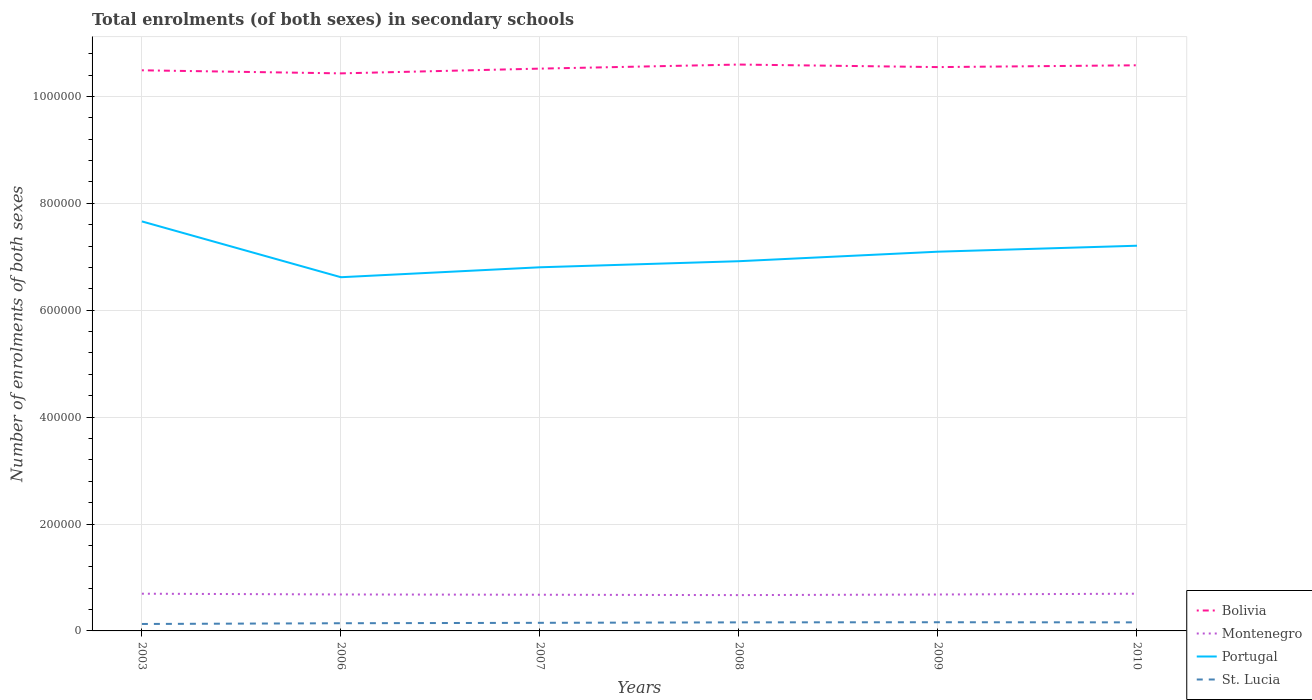Does the line corresponding to Portugal intersect with the line corresponding to St. Lucia?
Offer a very short reply. No. Across all years, what is the maximum number of enrolments in secondary schools in Portugal?
Offer a very short reply. 6.62e+05. What is the total number of enrolments in secondary schools in Bolivia in the graph?
Offer a terse response. -1.65e+04. What is the difference between the highest and the second highest number of enrolments in secondary schools in Montenegro?
Your response must be concise. 2612. Are the values on the major ticks of Y-axis written in scientific E-notation?
Your response must be concise. No. Does the graph contain grids?
Give a very brief answer. Yes. What is the title of the graph?
Provide a succinct answer. Total enrolments (of both sexes) in secondary schools. Does "Malaysia" appear as one of the legend labels in the graph?
Your answer should be very brief. No. What is the label or title of the Y-axis?
Make the answer very short. Number of enrolments of both sexes. What is the Number of enrolments of both sexes in Bolivia in 2003?
Your answer should be compact. 1.05e+06. What is the Number of enrolments of both sexes in Montenegro in 2003?
Your answer should be compact. 6.96e+04. What is the Number of enrolments of both sexes in Portugal in 2003?
Ensure brevity in your answer.  7.66e+05. What is the Number of enrolments of both sexes of St. Lucia in 2003?
Your answer should be compact. 1.30e+04. What is the Number of enrolments of both sexes in Bolivia in 2006?
Make the answer very short. 1.04e+06. What is the Number of enrolments of both sexes in Montenegro in 2006?
Your answer should be very brief. 6.82e+04. What is the Number of enrolments of both sexes in Portugal in 2006?
Give a very brief answer. 6.62e+05. What is the Number of enrolments of both sexes in St. Lucia in 2006?
Provide a succinct answer. 1.44e+04. What is the Number of enrolments of both sexes of Bolivia in 2007?
Your answer should be very brief. 1.05e+06. What is the Number of enrolments of both sexes in Montenegro in 2007?
Your answer should be compact. 6.77e+04. What is the Number of enrolments of both sexes of Portugal in 2007?
Ensure brevity in your answer.  6.80e+05. What is the Number of enrolments of both sexes of St. Lucia in 2007?
Offer a terse response. 1.51e+04. What is the Number of enrolments of both sexes in Bolivia in 2008?
Provide a short and direct response. 1.06e+06. What is the Number of enrolments of both sexes of Montenegro in 2008?
Your response must be concise. 6.70e+04. What is the Number of enrolments of both sexes of Portugal in 2008?
Give a very brief answer. 6.92e+05. What is the Number of enrolments of both sexes of St. Lucia in 2008?
Provide a succinct answer. 1.60e+04. What is the Number of enrolments of both sexes in Bolivia in 2009?
Offer a terse response. 1.05e+06. What is the Number of enrolments of both sexes of Montenegro in 2009?
Your answer should be very brief. 6.81e+04. What is the Number of enrolments of both sexes in Portugal in 2009?
Provide a short and direct response. 7.10e+05. What is the Number of enrolments of both sexes in St. Lucia in 2009?
Your answer should be compact. 1.62e+04. What is the Number of enrolments of both sexes in Bolivia in 2010?
Your response must be concise. 1.06e+06. What is the Number of enrolments of both sexes in Montenegro in 2010?
Provide a short and direct response. 6.96e+04. What is the Number of enrolments of both sexes in Portugal in 2010?
Your answer should be compact. 7.21e+05. What is the Number of enrolments of both sexes in St. Lucia in 2010?
Provide a succinct answer. 1.60e+04. Across all years, what is the maximum Number of enrolments of both sexes in Bolivia?
Keep it short and to the point. 1.06e+06. Across all years, what is the maximum Number of enrolments of both sexes in Montenegro?
Your answer should be very brief. 6.96e+04. Across all years, what is the maximum Number of enrolments of both sexes in Portugal?
Offer a terse response. 7.66e+05. Across all years, what is the maximum Number of enrolments of both sexes of St. Lucia?
Provide a succinct answer. 1.62e+04. Across all years, what is the minimum Number of enrolments of both sexes in Bolivia?
Your response must be concise. 1.04e+06. Across all years, what is the minimum Number of enrolments of both sexes in Montenegro?
Your answer should be compact. 6.70e+04. Across all years, what is the minimum Number of enrolments of both sexes of Portugal?
Your answer should be very brief. 6.62e+05. Across all years, what is the minimum Number of enrolments of both sexes of St. Lucia?
Your answer should be very brief. 1.30e+04. What is the total Number of enrolments of both sexes of Bolivia in the graph?
Make the answer very short. 6.32e+06. What is the total Number of enrolments of both sexes in Montenegro in the graph?
Your answer should be very brief. 4.10e+05. What is the total Number of enrolments of both sexes of Portugal in the graph?
Your response must be concise. 4.23e+06. What is the total Number of enrolments of both sexes in St. Lucia in the graph?
Ensure brevity in your answer.  9.08e+04. What is the difference between the Number of enrolments of both sexes in Bolivia in 2003 and that in 2006?
Keep it short and to the point. 5754. What is the difference between the Number of enrolments of both sexes of Montenegro in 2003 and that in 2006?
Provide a succinct answer. 1409. What is the difference between the Number of enrolments of both sexes in Portugal in 2003 and that in 2006?
Give a very brief answer. 1.04e+05. What is the difference between the Number of enrolments of both sexes in St. Lucia in 2003 and that in 2006?
Offer a terse response. -1390. What is the difference between the Number of enrolments of both sexes of Bolivia in 2003 and that in 2007?
Your response must be concise. -3133. What is the difference between the Number of enrolments of both sexes in Montenegro in 2003 and that in 2007?
Provide a short and direct response. 1944. What is the difference between the Number of enrolments of both sexes in Portugal in 2003 and that in 2007?
Offer a terse response. 8.58e+04. What is the difference between the Number of enrolments of both sexes in St. Lucia in 2003 and that in 2007?
Your answer should be very brief. -2159. What is the difference between the Number of enrolments of both sexes in Bolivia in 2003 and that in 2008?
Make the answer very short. -1.08e+04. What is the difference between the Number of enrolments of both sexes of Montenegro in 2003 and that in 2008?
Provide a short and direct response. 2612. What is the difference between the Number of enrolments of both sexes of Portugal in 2003 and that in 2008?
Offer a terse response. 7.45e+04. What is the difference between the Number of enrolments of both sexes in St. Lucia in 2003 and that in 2008?
Offer a very short reply. -3027. What is the difference between the Number of enrolments of both sexes in Bolivia in 2003 and that in 2009?
Give a very brief answer. -5997. What is the difference between the Number of enrolments of both sexes of Montenegro in 2003 and that in 2009?
Make the answer very short. 1492. What is the difference between the Number of enrolments of both sexes of Portugal in 2003 and that in 2009?
Keep it short and to the point. 5.67e+04. What is the difference between the Number of enrolments of both sexes of St. Lucia in 2003 and that in 2009?
Make the answer very short. -3247. What is the difference between the Number of enrolments of both sexes of Bolivia in 2003 and that in 2010?
Provide a succinct answer. -9376. What is the difference between the Number of enrolments of both sexes in Montenegro in 2003 and that in 2010?
Make the answer very short. 8. What is the difference between the Number of enrolments of both sexes in Portugal in 2003 and that in 2010?
Give a very brief answer. 4.55e+04. What is the difference between the Number of enrolments of both sexes of St. Lucia in 2003 and that in 2010?
Your answer should be very brief. -3030. What is the difference between the Number of enrolments of both sexes of Bolivia in 2006 and that in 2007?
Provide a short and direct response. -8887. What is the difference between the Number of enrolments of both sexes of Montenegro in 2006 and that in 2007?
Make the answer very short. 535. What is the difference between the Number of enrolments of both sexes of Portugal in 2006 and that in 2007?
Give a very brief answer. -1.86e+04. What is the difference between the Number of enrolments of both sexes in St. Lucia in 2006 and that in 2007?
Ensure brevity in your answer.  -769. What is the difference between the Number of enrolments of both sexes in Bolivia in 2006 and that in 2008?
Provide a short and direct response. -1.65e+04. What is the difference between the Number of enrolments of both sexes of Montenegro in 2006 and that in 2008?
Keep it short and to the point. 1203. What is the difference between the Number of enrolments of both sexes of Portugal in 2006 and that in 2008?
Provide a short and direct response. -3.00e+04. What is the difference between the Number of enrolments of both sexes in St. Lucia in 2006 and that in 2008?
Provide a short and direct response. -1637. What is the difference between the Number of enrolments of both sexes in Bolivia in 2006 and that in 2009?
Offer a terse response. -1.18e+04. What is the difference between the Number of enrolments of both sexes in Montenegro in 2006 and that in 2009?
Offer a terse response. 83. What is the difference between the Number of enrolments of both sexes in Portugal in 2006 and that in 2009?
Your answer should be compact. -4.78e+04. What is the difference between the Number of enrolments of both sexes of St. Lucia in 2006 and that in 2009?
Provide a succinct answer. -1857. What is the difference between the Number of enrolments of both sexes in Bolivia in 2006 and that in 2010?
Ensure brevity in your answer.  -1.51e+04. What is the difference between the Number of enrolments of both sexes in Montenegro in 2006 and that in 2010?
Make the answer very short. -1401. What is the difference between the Number of enrolments of both sexes of Portugal in 2006 and that in 2010?
Provide a succinct answer. -5.89e+04. What is the difference between the Number of enrolments of both sexes of St. Lucia in 2006 and that in 2010?
Your answer should be very brief. -1640. What is the difference between the Number of enrolments of both sexes in Bolivia in 2007 and that in 2008?
Give a very brief answer. -7627. What is the difference between the Number of enrolments of both sexes in Montenegro in 2007 and that in 2008?
Offer a very short reply. 668. What is the difference between the Number of enrolments of both sexes in Portugal in 2007 and that in 2008?
Your answer should be compact. -1.14e+04. What is the difference between the Number of enrolments of both sexes of St. Lucia in 2007 and that in 2008?
Offer a very short reply. -868. What is the difference between the Number of enrolments of both sexes in Bolivia in 2007 and that in 2009?
Offer a very short reply. -2864. What is the difference between the Number of enrolments of both sexes in Montenegro in 2007 and that in 2009?
Keep it short and to the point. -452. What is the difference between the Number of enrolments of both sexes of Portugal in 2007 and that in 2009?
Make the answer very short. -2.92e+04. What is the difference between the Number of enrolments of both sexes in St. Lucia in 2007 and that in 2009?
Ensure brevity in your answer.  -1088. What is the difference between the Number of enrolments of both sexes in Bolivia in 2007 and that in 2010?
Keep it short and to the point. -6243. What is the difference between the Number of enrolments of both sexes in Montenegro in 2007 and that in 2010?
Your response must be concise. -1936. What is the difference between the Number of enrolments of both sexes of Portugal in 2007 and that in 2010?
Your answer should be compact. -4.04e+04. What is the difference between the Number of enrolments of both sexes of St. Lucia in 2007 and that in 2010?
Your answer should be compact. -871. What is the difference between the Number of enrolments of both sexes in Bolivia in 2008 and that in 2009?
Keep it short and to the point. 4763. What is the difference between the Number of enrolments of both sexes in Montenegro in 2008 and that in 2009?
Offer a very short reply. -1120. What is the difference between the Number of enrolments of both sexes in Portugal in 2008 and that in 2009?
Your answer should be very brief. -1.78e+04. What is the difference between the Number of enrolments of both sexes of St. Lucia in 2008 and that in 2009?
Provide a short and direct response. -220. What is the difference between the Number of enrolments of both sexes in Bolivia in 2008 and that in 2010?
Keep it short and to the point. 1384. What is the difference between the Number of enrolments of both sexes of Montenegro in 2008 and that in 2010?
Give a very brief answer. -2604. What is the difference between the Number of enrolments of both sexes of Portugal in 2008 and that in 2010?
Your response must be concise. -2.90e+04. What is the difference between the Number of enrolments of both sexes in Bolivia in 2009 and that in 2010?
Keep it short and to the point. -3379. What is the difference between the Number of enrolments of both sexes of Montenegro in 2009 and that in 2010?
Make the answer very short. -1484. What is the difference between the Number of enrolments of both sexes of Portugal in 2009 and that in 2010?
Keep it short and to the point. -1.12e+04. What is the difference between the Number of enrolments of both sexes of St. Lucia in 2009 and that in 2010?
Make the answer very short. 217. What is the difference between the Number of enrolments of both sexes of Bolivia in 2003 and the Number of enrolments of both sexes of Montenegro in 2006?
Keep it short and to the point. 9.81e+05. What is the difference between the Number of enrolments of both sexes of Bolivia in 2003 and the Number of enrolments of both sexes of Portugal in 2006?
Offer a very short reply. 3.87e+05. What is the difference between the Number of enrolments of both sexes of Bolivia in 2003 and the Number of enrolments of both sexes of St. Lucia in 2006?
Your response must be concise. 1.03e+06. What is the difference between the Number of enrolments of both sexes in Montenegro in 2003 and the Number of enrolments of both sexes in Portugal in 2006?
Offer a terse response. -5.92e+05. What is the difference between the Number of enrolments of both sexes in Montenegro in 2003 and the Number of enrolments of both sexes in St. Lucia in 2006?
Provide a short and direct response. 5.52e+04. What is the difference between the Number of enrolments of both sexes of Portugal in 2003 and the Number of enrolments of both sexes of St. Lucia in 2006?
Provide a succinct answer. 7.52e+05. What is the difference between the Number of enrolments of both sexes of Bolivia in 2003 and the Number of enrolments of both sexes of Montenegro in 2007?
Your answer should be compact. 9.81e+05. What is the difference between the Number of enrolments of both sexes in Bolivia in 2003 and the Number of enrolments of both sexes in Portugal in 2007?
Your response must be concise. 3.69e+05. What is the difference between the Number of enrolments of both sexes of Bolivia in 2003 and the Number of enrolments of both sexes of St. Lucia in 2007?
Your answer should be compact. 1.03e+06. What is the difference between the Number of enrolments of both sexes in Montenegro in 2003 and the Number of enrolments of both sexes in Portugal in 2007?
Give a very brief answer. -6.11e+05. What is the difference between the Number of enrolments of both sexes of Montenegro in 2003 and the Number of enrolments of both sexes of St. Lucia in 2007?
Your response must be concise. 5.45e+04. What is the difference between the Number of enrolments of both sexes in Portugal in 2003 and the Number of enrolments of both sexes in St. Lucia in 2007?
Provide a succinct answer. 7.51e+05. What is the difference between the Number of enrolments of both sexes in Bolivia in 2003 and the Number of enrolments of both sexes in Montenegro in 2008?
Offer a very short reply. 9.82e+05. What is the difference between the Number of enrolments of both sexes of Bolivia in 2003 and the Number of enrolments of both sexes of Portugal in 2008?
Make the answer very short. 3.57e+05. What is the difference between the Number of enrolments of both sexes in Bolivia in 2003 and the Number of enrolments of both sexes in St. Lucia in 2008?
Ensure brevity in your answer.  1.03e+06. What is the difference between the Number of enrolments of both sexes in Montenegro in 2003 and the Number of enrolments of both sexes in Portugal in 2008?
Give a very brief answer. -6.22e+05. What is the difference between the Number of enrolments of both sexes of Montenegro in 2003 and the Number of enrolments of both sexes of St. Lucia in 2008?
Offer a terse response. 5.36e+04. What is the difference between the Number of enrolments of both sexes of Portugal in 2003 and the Number of enrolments of both sexes of St. Lucia in 2008?
Keep it short and to the point. 7.50e+05. What is the difference between the Number of enrolments of both sexes of Bolivia in 2003 and the Number of enrolments of both sexes of Montenegro in 2009?
Your answer should be compact. 9.81e+05. What is the difference between the Number of enrolments of both sexes in Bolivia in 2003 and the Number of enrolments of both sexes in Portugal in 2009?
Ensure brevity in your answer.  3.39e+05. What is the difference between the Number of enrolments of both sexes of Bolivia in 2003 and the Number of enrolments of both sexes of St. Lucia in 2009?
Give a very brief answer. 1.03e+06. What is the difference between the Number of enrolments of both sexes of Montenegro in 2003 and the Number of enrolments of both sexes of Portugal in 2009?
Your answer should be very brief. -6.40e+05. What is the difference between the Number of enrolments of both sexes of Montenegro in 2003 and the Number of enrolments of both sexes of St. Lucia in 2009?
Make the answer very short. 5.34e+04. What is the difference between the Number of enrolments of both sexes of Portugal in 2003 and the Number of enrolments of both sexes of St. Lucia in 2009?
Keep it short and to the point. 7.50e+05. What is the difference between the Number of enrolments of both sexes in Bolivia in 2003 and the Number of enrolments of both sexes in Montenegro in 2010?
Your answer should be compact. 9.79e+05. What is the difference between the Number of enrolments of both sexes of Bolivia in 2003 and the Number of enrolments of both sexes of Portugal in 2010?
Your answer should be very brief. 3.28e+05. What is the difference between the Number of enrolments of both sexes of Bolivia in 2003 and the Number of enrolments of both sexes of St. Lucia in 2010?
Make the answer very short. 1.03e+06. What is the difference between the Number of enrolments of both sexes in Montenegro in 2003 and the Number of enrolments of both sexes in Portugal in 2010?
Your response must be concise. -6.51e+05. What is the difference between the Number of enrolments of both sexes of Montenegro in 2003 and the Number of enrolments of both sexes of St. Lucia in 2010?
Your answer should be compact. 5.36e+04. What is the difference between the Number of enrolments of both sexes in Portugal in 2003 and the Number of enrolments of both sexes in St. Lucia in 2010?
Provide a succinct answer. 7.50e+05. What is the difference between the Number of enrolments of both sexes in Bolivia in 2006 and the Number of enrolments of both sexes in Montenegro in 2007?
Your answer should be very brief. 9.75e+05. What is the difference between the Number of enrolments of both sexes of Bolivia in 2006 and the Number of enrolments of both sexes of Portugal in 2007?
Provide a short and direct response. 3.63e+05. What is the difference between the Number of enrolments of both sexes in Bolivia in 2006 and the Number of enrolments of both sexes in St. Lucia in 2007?
Your answer should be compact. 1.03e+06. What is the difference between the Number of enrolments of both sexes in Montenegro in 2006 and the Number of enrolments of both sexes in Portugal in 2007?
Ensure brevity in your answer.  -6.12e+05. What is the difference between the Number of enrolments of both sexes of Montenegro in 2006 and the Number of enrolments of both sexes of St. Lucia in 2007?
Make the answer very short. 5.31e+04. What is the difference between the Number of enrolments of both sexes in Portugal in 2006 and the Number of enrolments of both sexes in St. Lucia in 2007?
Ensure brevity in your answer.  6.47e+05. What is the difference between the Number of enrolments of both sexes in Bolivia in 2006 and the Number of enrolments of both sexes in Montenegro in 2008?
Your answer should be very brief. 9.76e+05. What is the difference between the Number of enrolments of both sexes in Bolivia in 2006 and the Number of enrolments of both sexes in Portugal in 2008?
Offer a very short reply. 3.51e+05. What is the difference between the Number of enrolments of both sexes in Bolivia in 2006 and the Number of enrolments of both sexes in St. Lucia in 2008?
Provide a short and direct response. 1.03e+06. What is the difference between the Number of enrolments of both sexes in Montenegro in 2006 and the Number of enrolments of both sexes in Portugal in 2008?
Your answer should be very brief. -6.23e+05. What is the difference between the Number of enrolments of both sexes in Montenegro in 2006 and the Number of enrolments of both sexes in St. Lucia in 2008?
Your answer should be very brief. 5.22e+04. What is the difference between the Number of enrolments of both sexes in Portugal in 2006 and the Number of enrolments of both sexes in St. Lucia in 2008?
Make the answer very short. 6.46e+05. What is the difference between the Number of enrolments of both sexes of Bolivia in 2006 and the Number of enrolments of both sexes of Montenegro in 2009?
Give a very brief answer. 9.75e+05. What is the difference between the Number of enrolments of both sexes in Bolivia in 2006 and the Number of enrolments of both sexes in Portugal in 2009?
Provide a succinct answer. 3.34e+05. What is the difference between the Number of enrolments of both sexes in Bolivia in 2006 and the Number of enrolments of both sexes in St. Lucia in 2009?
Offer a very short reply. 1.03e+06. What is the difference between the Number of enrolments of both sexes in Montenegro in 2006 and the Number of enrolments of both sexes in Portugal in 2009?
Your answer should be very brief. -6.41e+05. What is the difference between the Number of enrolments of both sexes of Montenegro in 2006 and the Number of enrolments of both sexes of St. Lucia in 2009?
Your response must be concise. 5.20e+04. What is the difference between the Number of enrolments of both sexes of Portugal in 2006 and the Number of enrolments of both sexes of St. Lucia in 2009?
Your response must be concise. 6.46e+05. What is the difference between the Number of enrolments of both sexes in Bolivia in 2006 and the Number of enrolments of both sexes in Montenegro in 2010?
Offer a very short reply. 9.74e+05. What is the difference between the Number of enrolments of both sexes in Bolivia in 2006 and the Number of enrolments of both sexes in Portugal in 2010?
Your answer should be very brief. 3.22e+05. What is the difference between the Number of enrolments of both sexes in Bolivia in 2006 and the Number of enrolments of both sexes in St. Lucia in 2010?
Your answer should be very brief. 1.03e+06. What is the difference between the Number of enrolments of both sexes in Montenegro in 2006 and the Number of enrolments of both sexes in Portugal in 2010?
Provide a succinct answer. -6.52e+05. What is the difference between the Number of enrolments of both sexes in Montenegro in 2006 and the Number of enrolments of both sexes in St. Lucia in 2010?
Provide a succinct answer. 5.22e+04. What is the difference between the Number of enrolments of both sexes of Portugal in 2006 and the Number of enrolments of both sexes of St. Lucia in 2010?
Provide a short and direct response. 6.46e+05. What is the difference between the Number of enrolments of both sexes in Bolivia in 2007 and the Number of enrolments of both sexes in Montenegro in 2008?
Your answer should be very brief. 9.85e+05. What is the difference between the Number of enrolments of both sexes in Bolivia in 2007 and the Number of enrolments of both sexes in Portugal in 2008?
Offer a very short reply. 3.60e+05. What is the difference between the Number of enrolments of both sexes in Bolivia in 2007 and the Number of enrolments of both sexes in St. Lucia in 2008?
Give a very brief answer. 1.04e+06. What is the difference between the Number of enrolments of both sexes of Montenegro in 2007 and the Number of enrolments of both sexes of Portugal in 2008?
Keep it short and to the point. -6.24e+05. What is the difference between the Number of enrolments of both sexes of Montenegro in 2007 and the Number of enrolments of both sexes of St. Lucia in 2008?
Offer a terse response. 5.17e+04. What is the difference between the Number of enrolments of both sexes of Portugal in 2007 and the Number of enrolments of both sexes of St. Lucia in 2008?
Provide a short and direct response. 6.64e+05. What is the difference between the Number of enrolments of both sexes of Bolivia in 2007 and the Number of enrolments of both sexes of Montenegro in 2009?
Offer a very short reply. 9.84e+05. What is the difference between the Number of enrolments of both sexes in Bolivia in 2007 and the Number of enrolments of both sexes in Portugal in 2009?
Your response must be concise. 3.42e+05. What is the difference between the Number of enrolments of both sexes of Bolivia in 2007 and the Number of enrolments of both sexes of St. Lucia in 2009?
Keep it short and to the point. 1.04e+06. What is the difference between the Number of enrolments of both sexes in Montenegro in 2007 and the Number of enrolments of both sexes in Portugal in 2009?
Your answer should be compact. -6.42e+05. What is the difference between the Number of enrolments of both sexes in Montenegro in 2007 and the Number of enrolments of both sexes in St. Lucia in 2009?
Make the answer very short. 5.14e+04. What is the difference between the Number of enrolments of both sexes of Portugal in 2007 and the Number of enrolments of both sexes of St. Lucia in 2009?
Keep it short and to the point. 6.64e+05. What is the difference between the Number of enrolments of both sexes in Bolivia in 2007 and the Number of enrolments of both sexes in Montenegro in 2010?
Your answer should be very brief. 9.82e+05. What is the difference between the Number of enrolments of both sexes of Bolivia in 2007 and the Number of enrolments of both sexes of Portugal in 2010?
Offer a terse response. 3.31e+05. What is the difference between the Number of enrolments of both sexes in Bolivia in 2007 and the Number of enrolments of both sexes in St. Lucia in 2010?
Offer a very short reply. 1.04e+06. What is the difference between the Number of enrolments of both sexes of Montenegro in 2007 and the Number of enrolments of both sexes of Portugal in 2010?
Your answer should be very brief. -6.53e+05. What is the difference between the Number of enrolments of both sexes in Montenegro in 2007 and the Number of enrolments of both sexes in St. Lucia in 2010?
Ensure brevity in your answer.  5.17e+04. What is the difference between the Number of enrolments of both sexes of Portugal in 2007 and the Number of enrolments of both sexes of St. Lucia in 2010?
Offer a very short reply. 6.64e+05. What is the difference between the Number of enrolments of both sexes in Bolivia in 2008 and the Number of enrolments of both sexes in Montenegro in 2009?
Offer a very short reply. 9.92e+05. What is the difference between the Number of enrolments of both sexes in Bolivia in 2008 and the Number of enrolments of both sexes in Portugal in 2009?
Keep it short and to the point. 3.50e+05. What is the difference between the Number of enrolments of both sexes of Bolivia in 2008 and the Number of enrolments of both sexes of St. Lucia in 2009?
Your answer should be compact. 1.04e+06. What is the difference between the Number of enrolments of both sexes of Montenegro in 2008 and the Number of enrolments of both sexes of Portugal in 2009?
Give a very brief answer. -6.43e+05. What is the difference between the Number of enrolments of both sexes of Montenegro in 2008 and the Number of enrolments of both sexes of St. Lucia in 2009?
Your answer should be very brief. 5.08e+04. What is the difference between the Number of enrolments of both sexes of Portugal in 2008 and the Number of enrolments of both sexes of St. Lucia in 2009?
Offer a terse response. 6.75e+05. What is the difference between the Number of enrolments of both sexes in Bolivia in 2008 and the Number of enrolments of both sexes in Montenegro in 2010?
Offer a terse response. 9.90e+05. What is the difference between the Number of enrolments of both sexes of Bolivia in 2008 and the Number of enrolments of both sexes of Portugal in 2010?
Ensure brevity in your answer.  3.39e+05. What is the difference between the Number of enrolments of both sexes in Bolivia in 2008 and the Number of enrolments of both sexes in St. Lucia in 2010?
Provide a succinct answer. 1.04e+06. What is the difference between the Number of enrolments of both sexes of Montenegro in 2008 and the Number of enrolments of both sexes of Portugal in 2010?
Your answer should be very brief. -6.54e+05. What is the difference between the Number of enrolments of both sexes in Montenegro in 2008 and the Number of enrolments of both sexes in St. Lucia in 2010?
Your response must be concise. 5.10e+04. What is the difference between the Number of enrolments of both sexes in Portugal in 2008 and the Number of enrolments of both sexes in St. Lucia in 2010?
Keep it short and to the point. 6.76e+05. What is the difference between the Number of enrolments of both sexes of Bolivia in 2009 and the Number of enrolments of both sexes of Montenegro in 2010?
Keep it short and to the point. 9.85e+05. What is the difference between the Number of enrolments of both sexes of Bolivia in 2009 and the Number of enrolments of both sexes of Portugal in 2010?
Provide a succinct answer. 3.34e+05. What is the difference between the Number of enrolments of both sexes in Bolivia in 2009 and the Number of enrolments of both sexes in St. Lucia in 2010?
Provide a succinct answer. 1.04e+06. What is the difference between the Number of enrolments of both sexes in Montenegro in 2009 and the Number of enrolments of both sexes in Portugal in 2010?
Keep it short and to the point. -6.53e+05. What is the difference between the Number of enrolments of both sexes in Montenegro in 2009 and the Number of enrolments of both sexes in St. Lucia in 2010?
Your answer should be compact. 5.21e+04. What is the difference between the Number of enrolments of both sexes of Portugal in 2009 and the Number of enrolments of both sexes of St. Lucia in 2010?
Offer a terse response. 6.94e+05. What is the average Number of enrolments of both sexes of Bolivia per year?
Ensure brevity in your answer.  1.05e+06. What is the average Number of enrolments of both sexes of Montenegro per year?
Keep it short and to the point. 6.84e+04. What is the average Number of enrolments of both sexes in Portugal per year?
Your response must be concise. 7.05e+05. What is the average Number of enrolments of both sexes in St. Lucia per year?
Offer a very short reply. 1.51e+04. In the year 2003, what is the difference between the Number of enrolments of both sexes in Bolivia and Number of enrolments of both sexes in Montenegro?
Make the answer very short. 9.79e+05. In the year 2003, what is the difference between the Number of enrolments of both sexes of Bolivia and Number of enrolments of both sexes of Portugal?
Keep it short and to the point. 2.83e+05. In the year 2003, what is the difference between the Number of enrolments of both sexes in Bolivia and Number of enrolments of both sexes in St. Lucia?
Offer a terse response. 1.04e+06. In the year 2003, what is the difference between the Number of enrolments of both sexes of Montenegro and Number of enrolments of both sexes of Portugal?
Make the answer very short. -6.97e+05. In the year 2003, what is the difference between the Number of enrolments of both sexes of Montenegro and Number of enrolments of both sexes of St. Lucia?
Offer a very short reply. 5.66e+04. In the year 2003, what is the difference between the Number of enrolments of both sexes of Portugal and Number of enrolments of both sexes of St. Lucia?
Your answer should be very brief. 7.53e+05. In the year 2006, what is the difference between the Number of enrolments of both sexes in Bolivia and Number of enrolments of both sexes in Montenegro?
Ensure brevity in your answer.  9.75e+05. In the year 2006, what is the difference between the Number of enrolments of both sexes of Bolivia and Number of enrolments of both sexes of Portugal?
Your answer should be very brief. 3.81e+05. In the year 2006, what is the difference between the Number of enrolments of both sexes of Bolivia and Number of enrolments of both sexes of St. Lucia?
Ensure brevity in your answer.  1.03e+06. In the year 2006, what is the difference between the Number of enrolments of both sexes of Montenegro and Number of enrolments of both sexes of Portugal?
Keep it short and to the point. -5.94e+05. In the year 2006, what is the difference between the Number of enrolments of both sexes of Montenegro and Number of enrolments of both sexes of St. Lucia?
Ensure brevity in your answer.  5.38e+04. In the year 2006, what is the difference between the Number of enrolments of both sexes in Portugal and Number of enrolments of both sexes in St. Lucia?
Your answer should be very brief. 6.47e+05. In the year 2007, what is the difference between the Number of enrolments of both sexes of Bolivia and Number of enrolments of both sexes of Montenegro?
Your response must be concise. 9.84e+05. In the year 2007, what is the difference between the Number of enrolments of both sexes of Bolivia and Number of enrolments of both sexes of Portugal?
Provide a short and direct response. 3.72e+05. In the year 2007, what is the difference between the Number of enrolments of both sexes in Bolivia and Number of enrolments of both sexes in St. Lucia?
Make the answer very short. 1.04e+06. In the year 2007, what is the difference between the Number of enrolments of both sexes of Montenegro and Number of enrolments of both sexes of Portugal?
Give a very brief answer. -6.13e+05. In the year 2007, what is the difference between the Number of enrolments of both sexes in Montenegro and Number of enrolments of both sexes in St. Lucia?
Offer a very short reply. 5.25e+04. In the year 2007, what is the difference between the Number of enrolments of both sexes in Portugal and Number of enrolments of both sexes in St. Lucia?
Provide a succinct answer. 6.65e+05. In the year 2008, what is the difference between the Number of enrolments of both sexes in Bolivia and Number of enrolments of both sexes in Montenegro?
Your response must be concise. 9.93e+05. In the year 2008, what is the difference between the Number of enrolments of both sexes of Bolivia and Number of enrolments of both sexes of Portugal?
Give a very brief answer. 3.68e+05. In the year 2008, what is the difference between the Number of enrolments of both sexes of Bolivia and Number of enrolments of both sexes of St. Lucia?
Provide a succinct answer. 1.04e+06. In the year 2008, what is the difference between the Number of enrolments of both sexes of Montenegro and Number of enrolments of both sexes of Portugal?
Ensure brevity in your answer.  -6.25e+05. In the year 2008, what is the difference between the Number of enrolments of both sexes in Montenegro and Number of enrolments of both sexes in St. Lucia?
Your answer should be compact. 5.10e+04. In the year 2008, what is the difference between the Number of enrolments of both sexes of Portugal and Number of enrolments of both sexes of St. Lucia?
Give a very brief answer. 6.76e+05. In the year 2009, what is the difference between the Number of enrolments of both sexes in Bolivia and Number of enrolments of both sexes in Montenegro?
Make the answer very short. 9.87e+05. In the year 2009, what is the difference between the Number of enrolments of both sexes in Bolivia and Number of enrolments of both sexes in Portugal?
Give a very brief answer. 3.45e+05. In the year 2009, what is the difference between the Number of enrolments of both sexes in Bolivia and Number of enrolments of both sexes in St. Lucia?
Your answer should be compact. 1.04e+06. In the year 2009, what is the difference between the Number of enrolments of both sexes in Montenegro and Number of enrolments of both sexes in Portugal?
Provide a succinct answer. -6.41e+05. In the year 2009, what is the difference between the Number of enrolments of both sexes in Montenegro and Number of enrolments of both sexes in St. Lucia?
Give a very brief answer. 5.19e+04. In the year 2009, what is the difference between the Number of enrolments of both sexes of Portugal and Number of enrolments of both sexes of St. Lucia?
Your answer should be compact. 6.93e+05. In the year 2010, what is the difference between the Number of enrolments of both sexes of Bolivia and Number of enrolments of both sexes of Montenegro?
Your response must be concise. 9.89e+05. In the year 2010, what is the difference between the Number of enrolments of both sexes in Bolivia and Number of enrolments of both sexes in Portugal?
Offer a very short reply. 3.38e+05. In the year 2010, what is the difference between the Number of enrolments of both sexes in Bolivia and Number of enrolments of both sexes in St. Lucia?
Make the answer very short. 1.04e+06. In the year 2010, what is the difference between the Number of enrolments of both sexes in Montenegro and Number of enrolments of both sexes in Portugal?
Give a very brief answer. -6.51e+05. In the year 2010, what is the difference between the Number of enrolments of both sexes in Montenegro and Number of enrolments of both sexes in St. Lucia?
Keep it short and to the point. 5.36e+04. In the year 2010, what is the difference between the Number of enrolments of both sexes in Portugal and Number of enrolments of both sexes in St. Lucia?
Make the answer very short. 7.05e+05. What is the ratio of the Number of enrolments of both sexes in Montenegro in 2003 to that in 2006?
Give a very brief answer. 1.02. What is the ratio of the Number of enrolments of both sexes of Portugal in 2003 to that in 2006?
Offer a very short reply. 1.16. What is the ratio of the Number of enrolments of both sexes of St. Lucia in 2003 to that in 2006?
Provide a succinct answer. 0.9. What is the ratio of the Number of enrolments of both sexes of Bolivia in 2003 to that in 2007?
Your response must be concise. 1. What is the ratio of the Number of enrolments of both sexes in Montenegro in 2003 to that in 2007?
Give a very brief answer. 1.03. What is the ratio of the Number of enrolments of both sexes of Portugal in 2003 to that in 2007?
Ensure brevity in your answer.  1.13. What is the ratio of the Number of enrolments of both sexes of St. Lucia in 2003 to that in 2007?
Provide a succinct answer. 0.86. What is the ratio of the Number of enrolments of both sexes in Bolivia in 2003 to that in 2008?
Your response must be concise. 0.99. What is the ratio of the Number of enrolments of both sexes in Montenegro in 2003 to that in 2008?
Make the answer very short. 1.04. What is the ratio of the Number of enrolments of both sexes of Portugal in 2003 to that in 2008?
Your response must be concise. 1.11. What is the ratio of the Number of enrolments of both sexes in St. Lucia in 2003 to that in 2008?
Make the answer very short. 0.81. What is the ratio of the Number of enrolments of both sexes in Montenegro in 2003 to that in 2009?
Keep it short and to the point. 1.02. What is the ratio of the Number of enrolments of both sexes of Portugal in 2003 to that in 2009?
Provide a short and direct response. 1.08. What is the ratio of the Number of enrolments of both sexes in Portugal in 2003 to that in 2010?
Your answer should be compact. 1.06. What is the ratio of the Number of enrolments of both sexes of St. Lucia in 2003 to that in 2010?
Provide a succinct answer. 0.81. What is the ratio of the Number of enrolments of both sexes in Bolivia in 2006 to that in 2007?
Offer a terse response. 0.99. What is the ratio of the Number of enrolments of both sexes of Montenegro in 2006 to that in 2007?
Your answer should be very brief. 1.01. What is the ratio of the Number of enrolments of both sexes in Portugal in 2006 to that in 2007?
Your answer should be very brief. 0.97. What is the ratio of the Number of enrolments of both sexes in St. Lucia in 2006 to that in 2007?
Give a very brief answer. 0.95. What is the ratio of the Number of enrolments of both sexes in Bolivia in 2006 to that in 2008?
Provide a short and direct response. 0.98. What is the ratio of the Number of enrolments of both sexes in Montenegro in 2006 to that in 2008?
Offer a terse response. 1.02. What is the ratio of the Number of enrolments of both sexes in Portugal in 2006 to that in 2008?
Your response must be concise. 0.96. What is the ratio of the Number of enrolments of both sexes in St. Lucia in 2006 to that in 2008?
Your answer should be compact. 0.9. What is the ratio of the Number of enrolments of both sexes of Bolivia in 2006 to that in 2009?
Offer a very short reply. 0.99. What is the ratio of the Number of enrolments of both sexes in Montenegro in 2006 to that in 2009?
Make the answer very short. 1. What is the ratio of the Number of enrolments of both sexes of Portugal in 2006 to that in 2009?
Provide a succinct answer. 0.93. What is the ratio of the Number of enrolments of both sexes in St. Lucia in 2006 to that in 2009?
Give a very brief answer. 0.89. What is the ratio of the Number of enrolments of both sexes in Bolivia in 2006 to that in 2010?
Give a very brief answer. 0.99. What is the ratio of the Number of enrolments of both sexes in Montenegro in 2006 to that in 2010?
Your answer should be compact. 0.98. What is the ratio of the Number of enrolments of both sexes of Portugal in 2006 to that in 2010?
Provide a succinct answer. 0.92. What is the ratio of the Number of enrolments of both sexes in St. Lucia in 2006 to that in 2010?
Ensure brevity in your answer.  0.9. What is the ratio of the Number of enrolments of both sexes in Montenegro in 2007 to that in 2008?
Keep it short and to the point. 1.01. What is the ratio of the Number of enrolments of both sexes of Portugal in 2007 to that in 2008?
Your answer should be compact. 0.98. What is the ratio of the Number of enrolments of both sexes of St. Lucia in 2007 to that in 2008?
Offer a very short reply. 0.95. What is the ratio of the Number of enrolments of both sexes in Bolivia in 2007 to that in 2009?
Offer a terse response. 1. What is the ratio of the Number of enrolments of both sexes in Portugal in 2007 to that in 2009?
Offer a very short reply. 0.96. What is the ratio of the Number of enrolments of both sexes in St. Lucia in 2007 to that in 2009?
Make the answer very short. 0.93. What is the ratio of the Number of enrolments of both sexes of Montenegro in 2007 to that in 2010?
Ensure brevity in your answer.  0.97. What is the ratio of the Number of enrolments of both sexes in Portugal in 2007 to that in 2010?
Your response must be concise. 0.94. What is the ratio of the Number of enrolments of both sexes of St. Lucia in 2007 to that in 2010?
Offer a terse response. 0.95. What is the ratio of the Number of enrolments of both sexes of Bolivia in 2008 to that in 2009?
Keep it short and to the point. 1. What is the ratio of the Number of enrolments of both sexes of Montenegro in 2008 to that in 2009?
Your response must be concise. 0.98. What is the ratio of the Number of enrolments of both sexes in Portugal in 2008 to that in 2009?
Offer a terse response. 0.97. What is the ratio of the Number of enrolments of both sexes of St. Lucia in 2008 to that in 2009?
Provide a short and direct response. 0.99. What is the ratio of the Number of enrolments of both sexes of Bolivia in 2008 to that in 2010?
Offer a very short reply. 1. What is the ratio of the Number of enrolments of both sexes in Montenegro in 2008 to that in 2010?
Your answer should be compact. 0.96. What is the ratio of the Number of enrolments of both sexes in Portugal in 2008 to that in 2010?
Ensure brevity in your answer.  0.96. What is the ratio of the Number of enrolments of both sexes in St. Lucia in 2008 to that in 2010?
Ensure brevity in your answer.  1. What is the ratio of the Number of enrolments of both sexes in Montenegro in 2009 to that in 2010?
Your response must be concise. 0.98. What is the ratio of the Number of enrolments of both sexes in Portugal in 2009 to that in 2010?
Provide a succinct answer. 0.98. What is the ratio of the Number of enrolments of both sexes of St. Lucia in 2009 to that in 2010?
Provide a short and direct response. 1.01. What is the difference between the highest and the second highest Number of enrolments of both sexes in Bolivia?
Offer a terse response. 1384. What is the difference between the highest and the second highest Number of enrolments of both sexes in Montenegro?
Provide a succinct answer. 8. What is the difference between the highest and the second highest Number of enrolments of both sexes of Portugal?
Give a very brief answer. 4.55e+04. What is the difference between the highest and the second highest Number of enrolments of both sexes of St. Lucia?
Ensure brevity in your answer.  217. What is the difference between the highest and the lowest Number of enrolments of both sexes in Bolivia?
Provide a short and direct response. 1.65e+04. What is the difference between the highest and the lowest Number of enrolments of both sexes in Montenegro?
Your answer should be compact. 2612. What is the difference between the highest and the lowest Number of enrolments of both sexes of Portugal?
Your answer should be compact. 1.04e+05. What is the difference between the highest and the lowest Number of enrolments of both sexes of St. Lucia?
Your answer should be compact. 3247. 